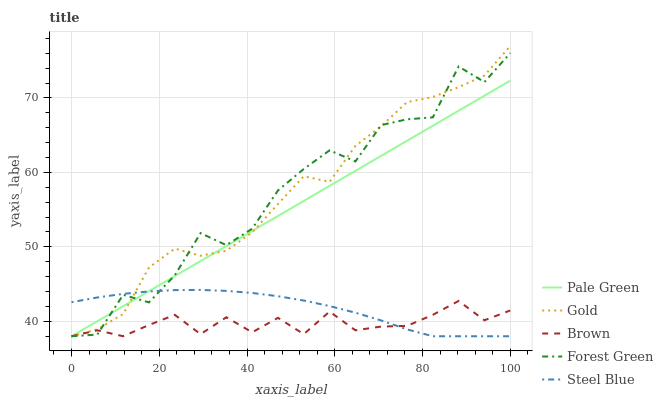Does Brown have the minimum area under the curve?
Answer yes or no. Yes. Does Gold have the maximum area under the curve?
Answer yes or no. Yes. Does Forest Green have the minimum area under the curve?
Answer yes or no. No. Does Forest Green have the maximum area under the curve?
Answer yes or no. No. Is Pale Green the smoothest?
Answer yes or no. Yes. Is Forest Green the roughest?
Answer yes or no. Yes. Is Forest Green the smoothest?
Answer yes or no. No. Is Pale Green the roughest?
Answer yes or no. No. Does Brown have the lowest value?
Answer yes or no. Yes. Does Gold have the highest value?
Answer yes or no. Yes. Does Forest Green have the highest value?
Answer yes or no. No. Does Forest Green intersect Gold?
Answer yes or no. Yes. Is Forest Green less than Gold?
Answer yes or no. No. Is Forest Green greater than Gold?
Answer yes or no. No. 